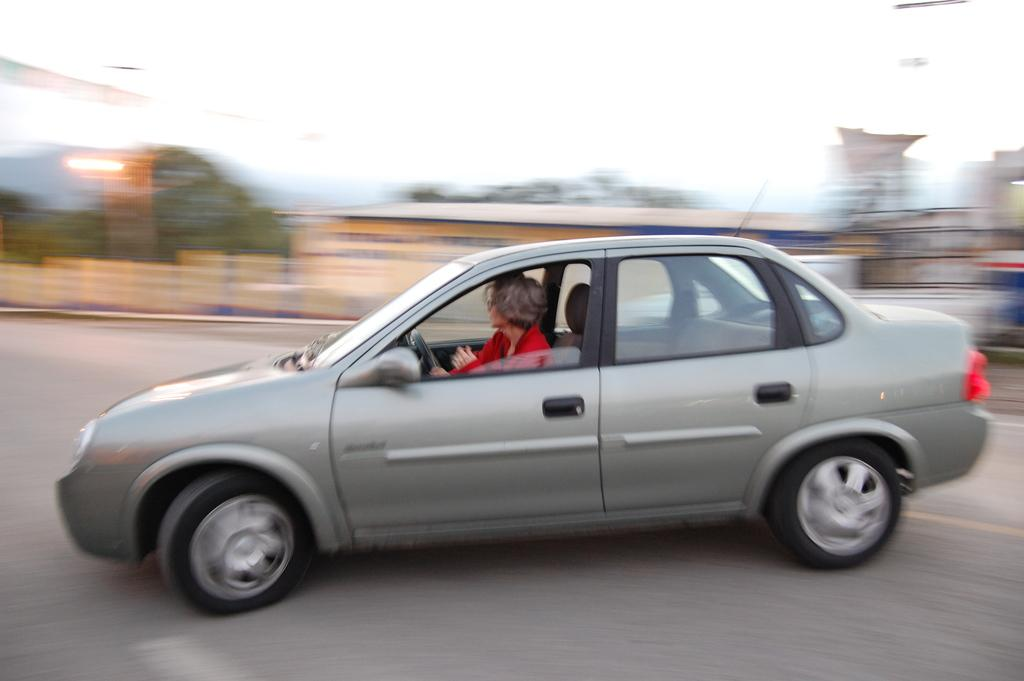What is the person in the image wearing? The person in the image is wearing a red shirt. What is the person doing in the image? The person is driving a vehicle. Where is the vehicle located in the image? The vehicle is on the road. What can be seen in the background of the image? There are trees, buildings, and the sky visible in the background of the image. How many cakes are being served in the park in the image? There is no park or cakes present in the image; it features a person driving a vehicle on the road. 